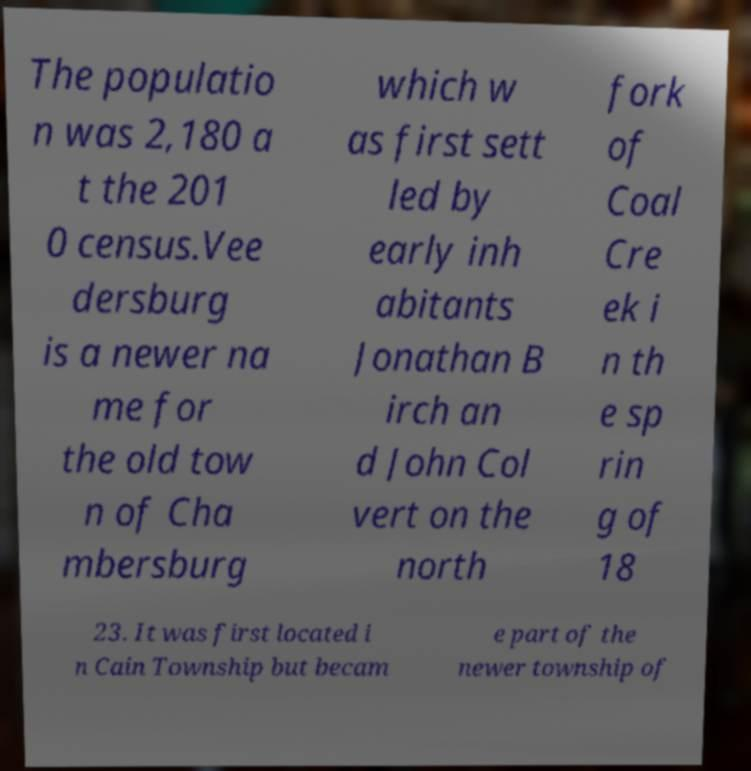Can you read and provide the text displayed in the image?This photo seems to have some interesting text. Can you extract and type it out for me? The populatio n was 2,180 a t the 201 0 census.Vee dersburg is a newer na me for the old tow n of Cha mbersburg which w as first sett led by early inh abitants Jonathan B irch an d John Col vert on the north fork of Coal Cre ek i n th e sp rin g of 18 23. It was first located i n Cain Township but becam e part of the newer township of 